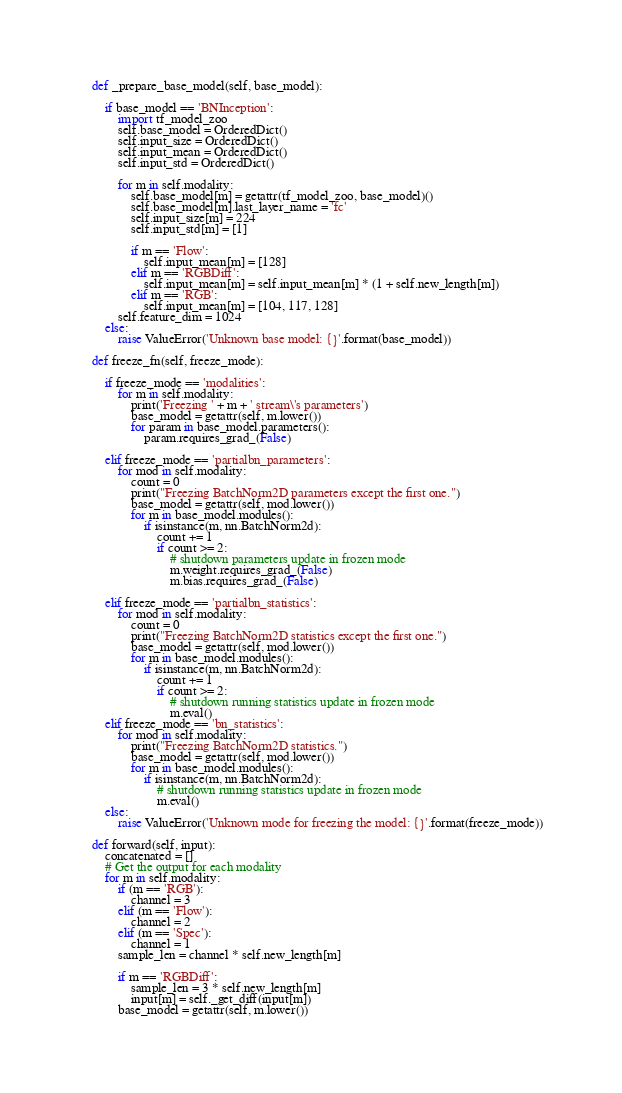<code> <loc_0><loc_0><loc_500><loc_500><_Python_>
    def _prepare_base_model(self, base_model):

        if base_model == 'BNInception':
            import tf_model_zoo
            self.base_model = OrderedDict()
            self.input_size = OrderedDict()
            self.input_mean = OrderedDict()
            self.input_std = OrderedDict()

            for m in self.modality:
                self.base_model[m] = getattr(tf_model_zoo, base_model)()
                self.base_model[m].last_layer_name = 'fc'
                self.input_size[m] = 224
                self.input_std[m] = [1]

                if m == 'Flow':
                    self.input_mean[m] = [128]
                elif m == 'RGBDiff':
                    self.input_mean[m] = self.input_mean[m] * (1 + self.new_length[m])
                elif m == 'RGB':
                    self.input_mean[m] = [104, 117, 128]
            self.feature_dim = 1024
        else:
            raise ValueError('Unknown base model: {}'.format(base_model))

    def freeze_fn(self, freeze_mode):

        if freeze_mode == 'modalities':
            for m in self.modality:
                print('Freezing ' + m + ' stream\'s parameters')
                base_model = getattr(self, m.lower())
                for param in base_model.parameters():
                    param.requires_grad_(False)

        elif freeze_mode == 'partialbn_parameters':
            for mod in self.modality:
                count = 0
                print("Freezing BatchNorm2D parameters except the first one.")
                base_model = getattr(self, mod.lower())
                for m in base_model.modules():
                    if isinstance(m, nn.BatchNorm2d):
                        count += 1
                        if count >= 2:
                            # shutdown parameters update in frozen mode
                            m.weight.requires_grad_(False)
                            m.bias.requires_grad_(False)

        elif freeze_mode == 'partialbn_statistics':
            for mod in self.modality:
                count = 0
                print("Freezing BatchNorm2D statistics except the first one.")
                base_model = getattr(self, mod.lower())
                for m in base_model.modules():
                    if isinstance(m, nn.BatchNorm2d):
                        count += 1
                        if count >= 2:
                            # shutdown running statistics update in frozen mode
                            m.eval()
        elif freeze_mode == 'bn_statistics':
            for mod in self.modality:
                print("Freezing BatchNorm2D statistics.")
                base_model = getattr(self, mod.lower())
                for m in base_model.modules():
                    if isinstance(m, nn.BatchNorm2d):
                        # shutdown running statistics update in frozen mode
                        m.eval()
        else:
            raise ValueError('Unknown mode for freezing the model: {}'.format(freeze_mode))

    def forward(self, input):
        concatenated = []
        # Get the output for each modality
        for m in self.modality:
            if (m == 'RGB'):
                channel = 3
            elif (m == 'Flow'):
                channel = 2
            elif (m == 'Spec'):
                channel = 1
            sample_len = channel * self.new_length[m]

            if m == 'RGBDiff':
                sample_len = 3 * self.new_length[m]
                input[m] = self._get_diff(input[m])
            base_model = getattr(self, m.lower())</code> 